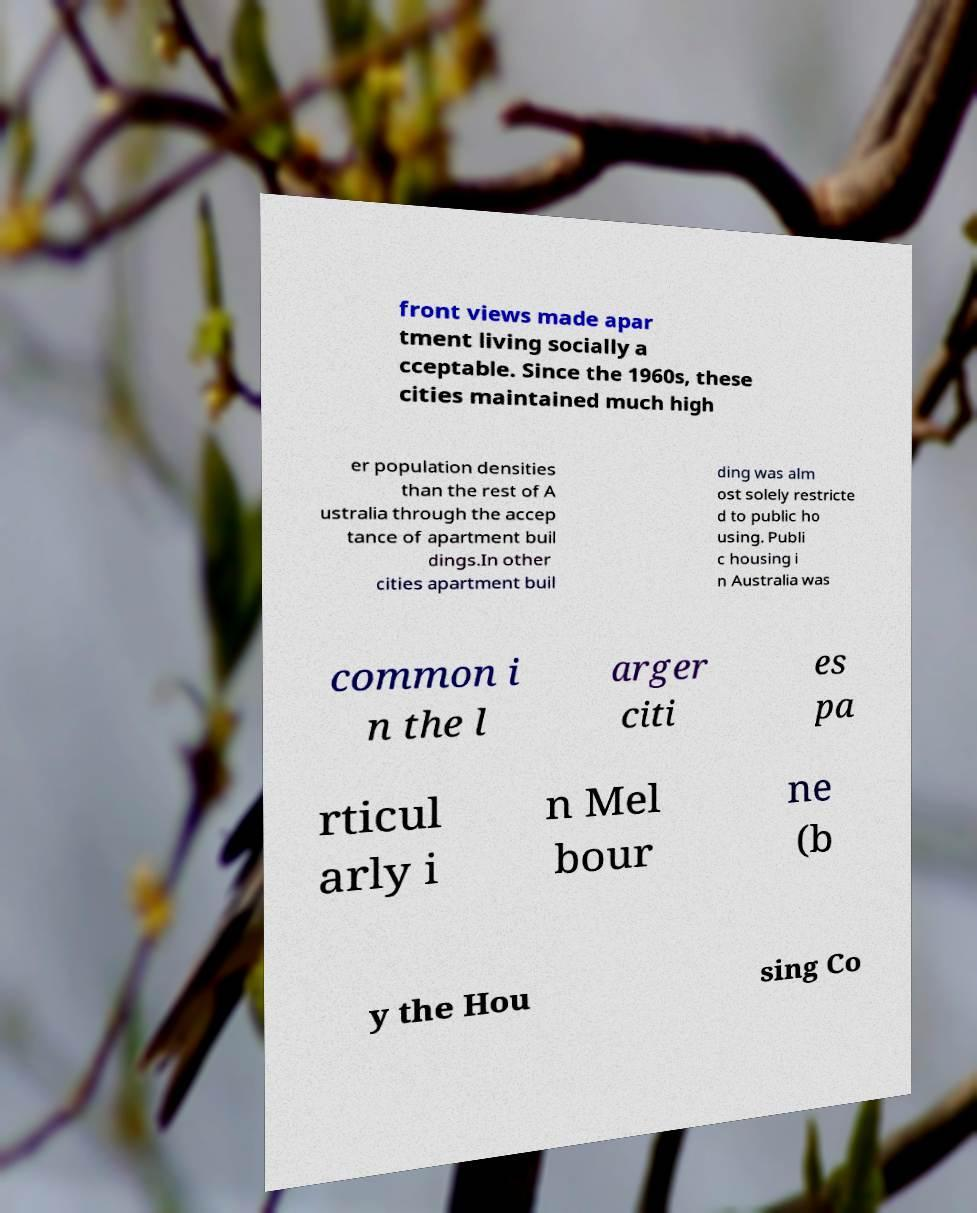Please read and relay the text visible in this image. What does it say? front views made apar tment living socially a cceptable. Since the 1960s, these cities maintained much high er population densities than the rest of A ustralia through the accep tance of apartment buil dings.In other cities apartment buil ding was alm ost solely restricte d to public ho using. Publi c housing i n Australia was common i n the l arger citi es pa rticul arly i n Mel bour ne (b y the Hou sing Co 